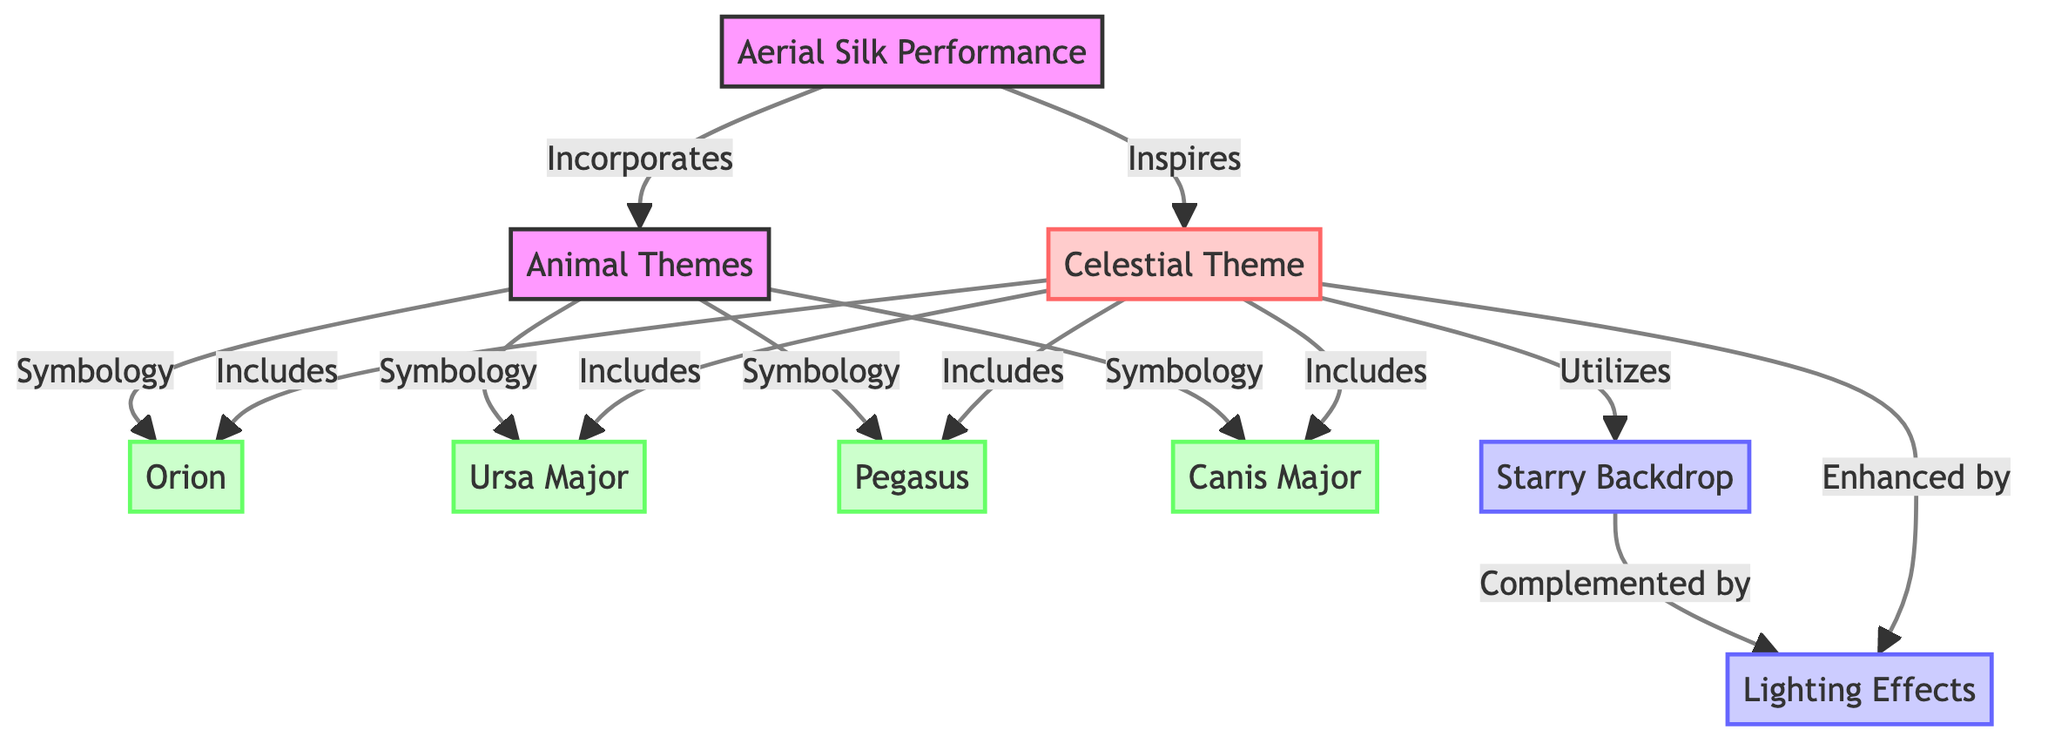What is the central theme of the Aerial Silk Performance? The diagram shows that the central theme of the Aerial Silk Performance is the Celestial Theme, which is directly connected to the Aerial Silk node via an "inspires" relationship.
Answer: Celestial Theme How many animal themes are included in the diagram? The diagram lists four animal themes connected to the Animal Themes node: Orion, Ursa Major, Pegasus, and Canis Major. Thus, there are a total of four animal themes represented.
Answer: 4 What does the Celestial Theme utilize as a backdrop? The diagram indicates that the Celestial Theme utilizes a Starry Backdrop, which is shown as a direct connection from the Celestial Theme node.
Answer: Starry Backdrop Which animal theme represents the symbol of the constellation Pegasus? Through the connections noted in the diagram, Pegasus is specifically listed under the Animal Themes node, indicating that it is a selected animal theme.
Answer: Pegasus How are lighting effects described relative to the Celestial Theme? The diagram specifies that Lighting Effects are enhanced by the Celestial Theme, indicating a supportive relationship where lighting complements the celestial aspects of the performance.
Answer: Enhanced by Which two elements are connected to the Starry Backdrop? The diagram shows two connections: the first is that the Starry Backdrop is utilized by the Celestial Theme, and the second is that it is complemented by Lighting effects. Hence, the two elements connected are Celestial Theme and Lighting.
Answer: Celestial Theme, Lighting What is the relationship between the Aerial Silk Performance and Animal Themes? In the diagram, the relationship shown is that the Aerial Silk Performance incorporates Animal Themes, meaning that animal themes are a significant part of the aerial silk routine.
Answer: Incorporates Which constellation is associated with the symbolology of the Canis Major? Canis Major is directly connected to the Animal Themes node, indicating it is part of the symbology in this context. Thus, it is associated like the others listed.
Answer: Canis Major 